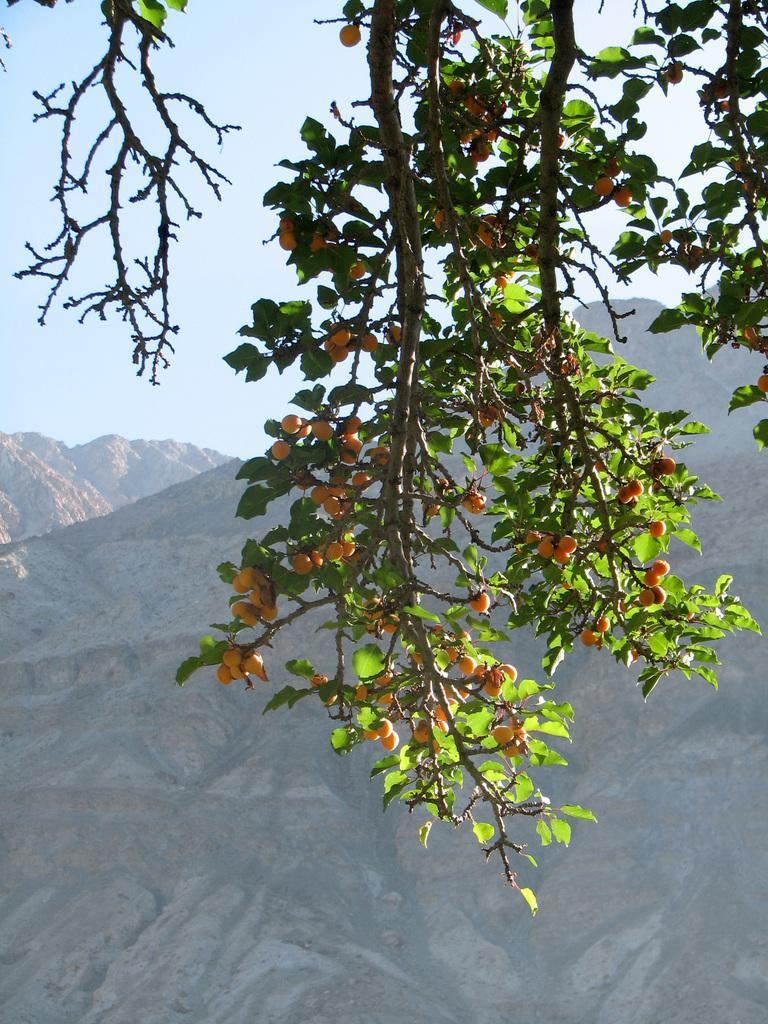Describe this image in one or two sentences. In the image we can see tree branches, leaves and orange colored fruits on it. There are mountains and a pale blue sky. 